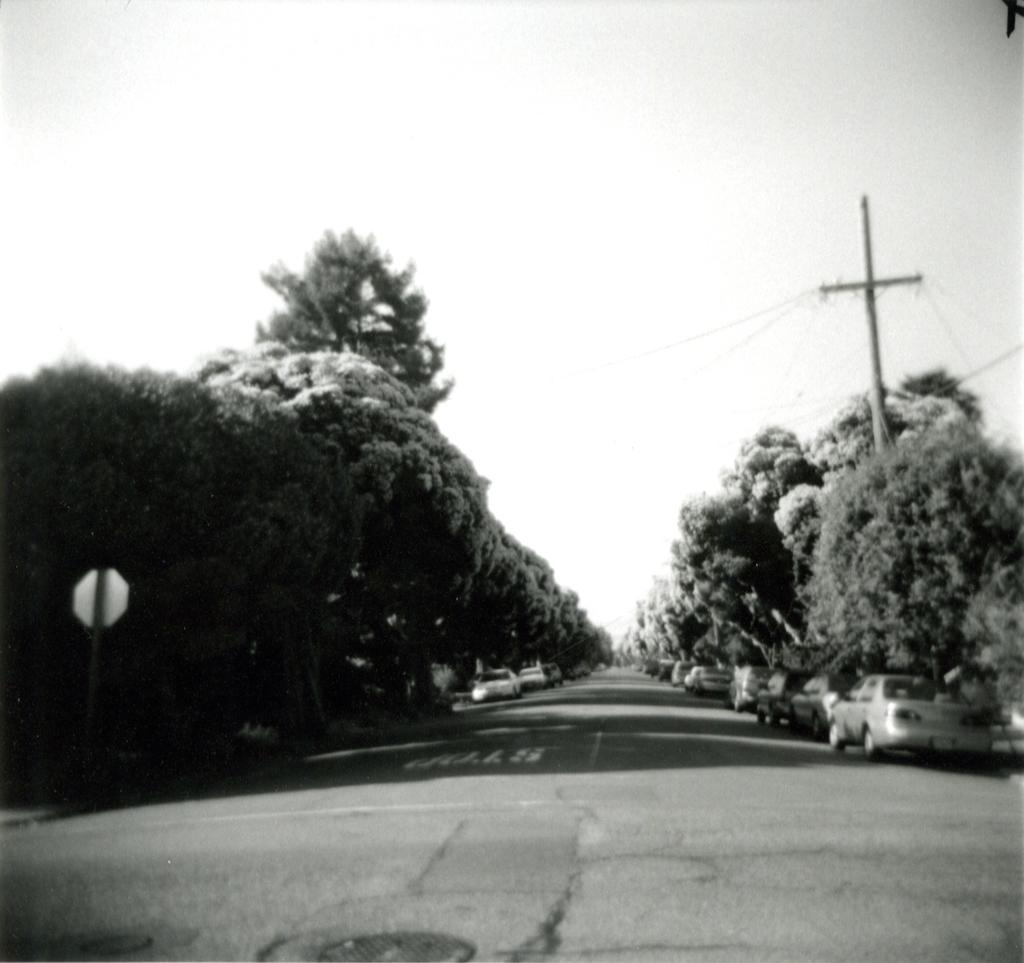What type of vegetation can be seen in the image? There are trees in the image. What can be seen on both sides of the road in the image? There are cars parked on both sides of the road. What is present in the image besides the trees and cars? There is a pole in the image. What is attached to the pole in the image? There is a signboard attached to the pole. How would you describe the sky in the image? The sky is cloudy in the image. Can you see a quilt hanging from the trees in the image? No, there is no quilt present in the image. Are there any goldfish swimming in the road in the image? No, there are no goldfish present in the image. 